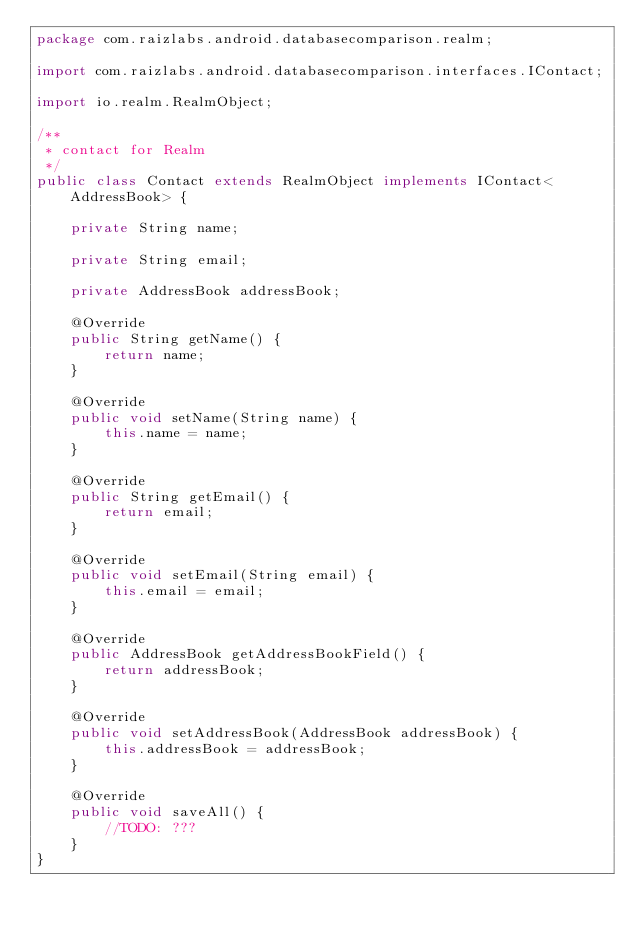<code> <loc_0><loc_0><loc_500><loc_500><_Java_>package com.raizlabs.android.databasecomparison.realm;

import com.raizlabs.android.databasecomparison.interfaces.IContact;

import io.realm.RealmObject;

/**
 * contact for Realm
 */
public class Contact extends RealmObject implements IContact<AddressBook> {

    private String name;

    private String email;

    private AddressBook addressBook;

    @Override
    public String getName() {
        return name;
    }

    @Override
    public void setName(String name) {
        this.name = name;
    }

    @Override
    public String getEmail() {
        return email;
    }

    @Override
    public void setEmail(String email) {
        this.email = email;
    }

    @Override
    public AddressBook getAddressBookField() {
        return addressBook;
    }

    @Override
    public void setAddressBook(AddressBook addressBook) {
        this.addressBook = addressBook;
    }

    @Override
    public void saveAll() {
        //TODO: ???
    }
}
</code> 